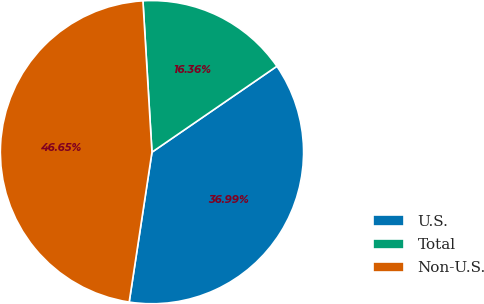<chart> <loc_0><loc_0><loc_500><loc_500><pie_chart><fcel>U.S.<fcel>Total<fcel>Non-U.S.<nl><fcel>36.99%<fcel>16.36%<fcel>46.65%<nl></chart> 